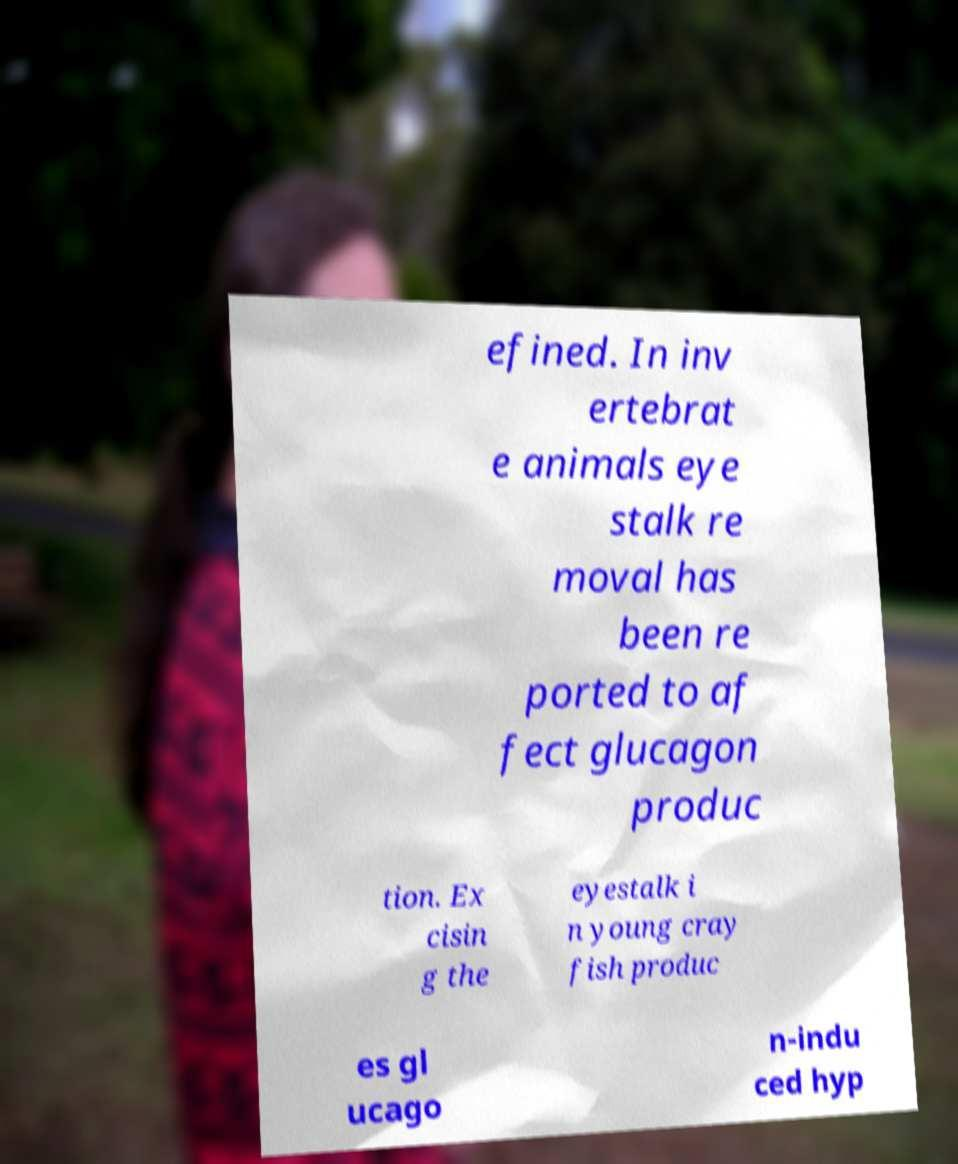Please read and relay the text visible in this image. What does it say? efined. In inv ertebrat e animals eye stalk re moval has been re ported to af fect glucagon produc tion. Ex cisin g the eyestalk i n young cray fish produc es gl ucago n-indu ced hyp 